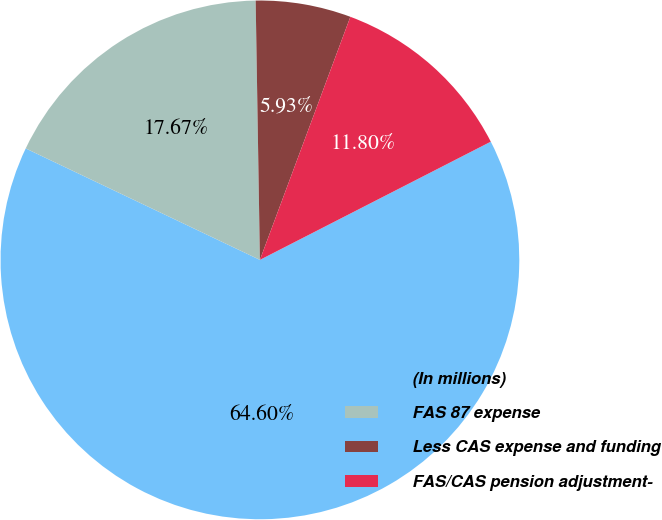Convert chart to OTSL. <chart><loc_0><loc_0><loc_500><loc_500><pie_chart><fcel>(In millions)<fcel>FAS 87 expense<fcel>Less CAS expense and funding<fcel>FAS/CAS pension adjustment-<nl><fcel>64.6%<fcel>17.67%<fcel>5.93%<fcel>11.8%<nl></chart> 